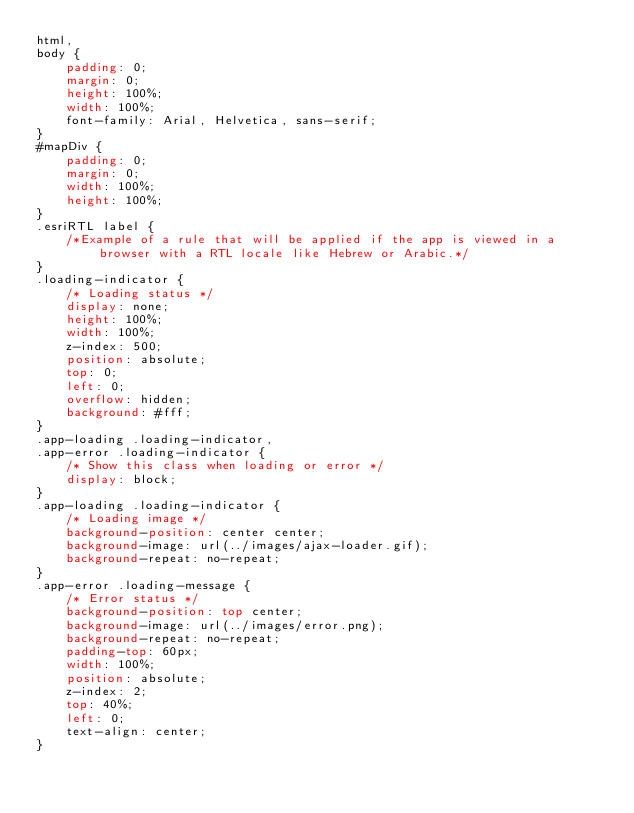Convert code to text. <code><loc_0><loc_0><loc_500><loc_500><_CSS_>html,
body {
    padding: 0;
    margin: 0;
    height: 100%;
    width: 100%;
    font-family: Arial, Helvetica, sans-serif;
}
#mapDiv {
    padding: 0;
    margin: 0;
    width: 100%;
    height: 100%;
}
.esriRTL label {
    /*Example of a rule that will be applied if the app is viewed in a browser with a RTL locale like Hebrew or Arabic.*/
}
.loading-indicator {
    /* Loading status */
    display: none;
    height: 100%;
    width: 100%;
    z-index: 500;
    position: absolute;
    top: 0;
    left: 0;
    overflow: hidden;
    background: #fff;
}
.app-loading .loading-indicator,
.app-error .loading-indicator {
    /* Show this class when loading or error */
    display: block;
}
.app-loading .loading-indicator {
    /* Loading image */
    background-position: center center;
    background-image: url(../images/ajax-loader.gif);
    background-repeat: no-repeat;
}
.app-error .loading-message {
    /* Error status */
    background-position: top center;
    background-image: url(../images/error.png);
    background-repeat: no-repeat;
    padding-top: 60px;
    width: 100%;
    position: absolute;
    z-index: 2;
    top: 40%;
    left: 0;
    text-align: center;
}</code> 